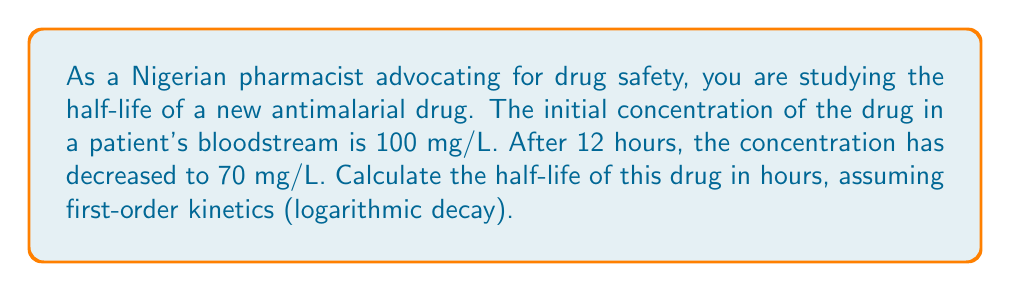Could you help me with this problem? To solve this problem, we'll use the first-order decay equation and the properties of logarithms:

1) The first-order decay equation is:
   $$ C_t = C_0 \cdot e^{-kt} $$
   where $C_t$ is the concentration at time $t$, $C_0$ is the initial concentration, $k$ is the decay constant, and $t$ is time.

2) We're given:
   $C_0 = 100$ mg/L
   $C_t = 70$ mg/L at $t = 12$ hours

3) Substituting these values:
   $$ 70 = 100 \cdot e^{-k \cdot 12} $$

4) Dividing both sides by 100:
   $$ 0.7 = e^{-12k} $$

5) Taking the natural logarithm of both sides:
   $$ \ln(0.7) = -12k $$

6) Solving for $k$:
   $$ k = -\frac{\ln(0.7)}{12} \approx 0.0297 \text{ hour}^{-1} $$

7) The half-life $t_{1/2}$ is related to $k$ by:
   $$ t_{1/2} = \frac{\ln(2)}{k} $$

8) Substituting our value for $k$:
   $$ t_{1/2} = \frac{\ln(2)}{0.0297} \approx 23.34 \text{ hours} $$

Therefore, the half-life of the antimalarial drug is approximately 23.34 hours.
Answer: The half-life of the antimalarial drug is approximately 23.34 hours. 